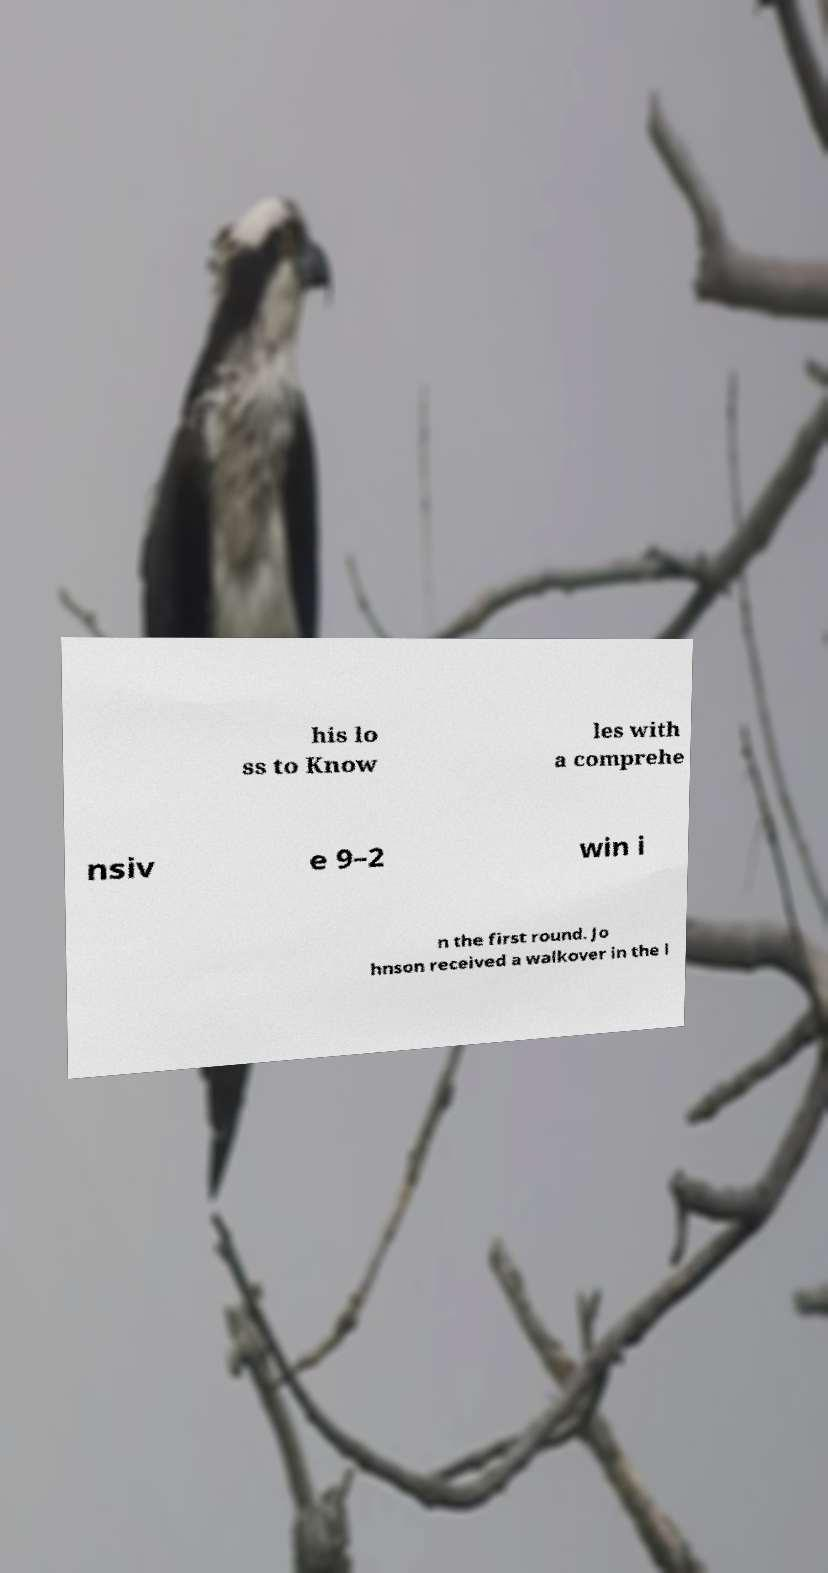I need the written content from this picture converted into text. Can you do that? his lo ss to Know les with a comprehe nsiv e 9–2 win i n the first round. Jo hnson received a walkover in the l 